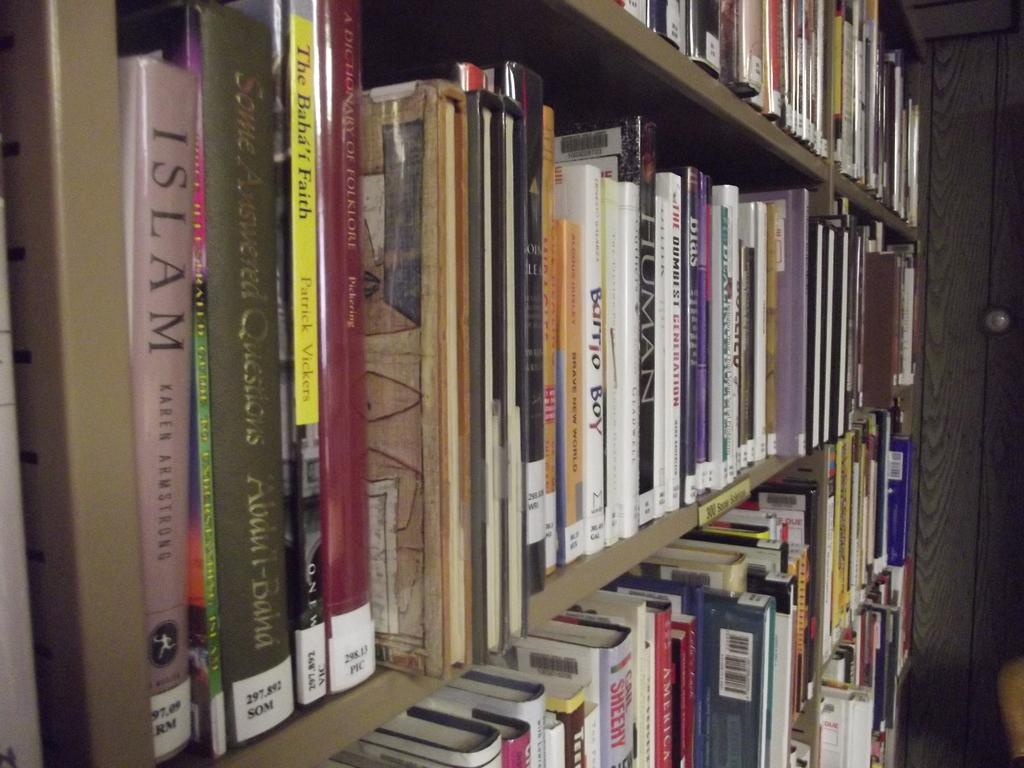<image>
Summarize the visual content of the image. A book shelf in a library full of books including one called Human. 